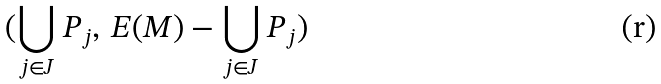Convert formula to latex. <formula><loc_0><loc_0><loc_500><loc_500>( \bigcup _ { j \in J } P _ { j } , \, E ( M ) - \bigcup _ { j \in J } P _ { j } )</formula> 